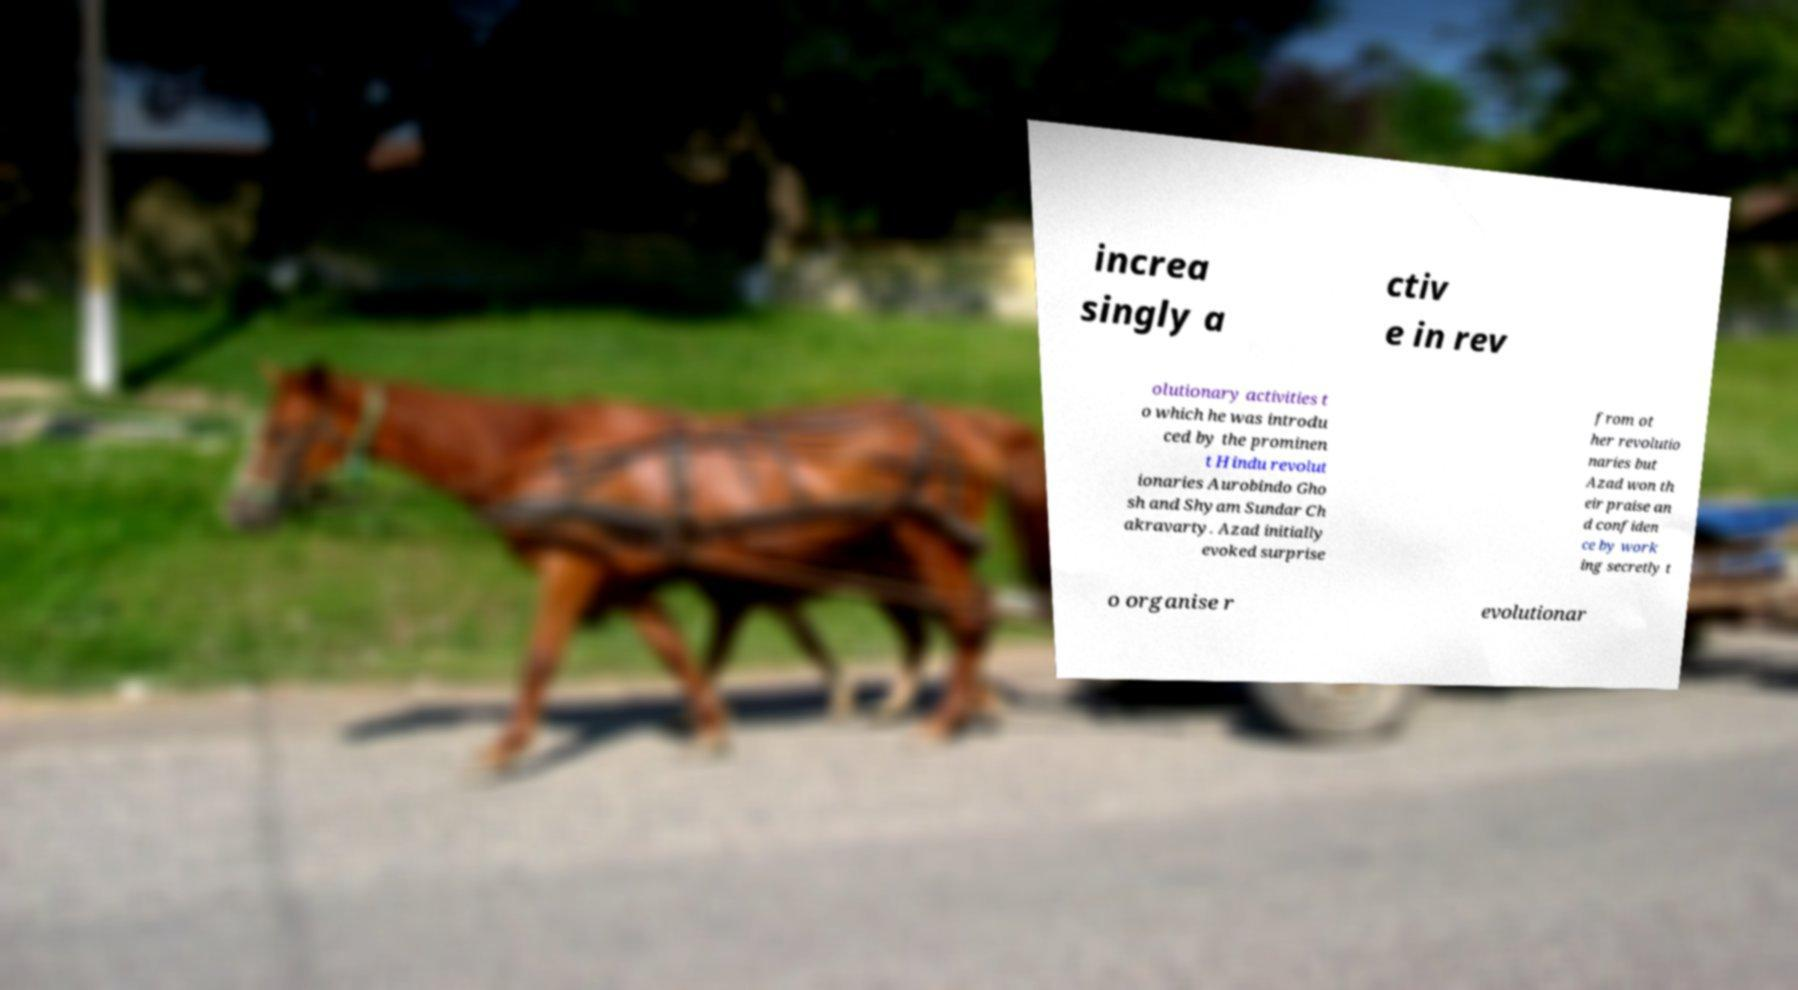Please identify and transcribe the text found in this image. increa singly a ctiv e in rev olutionary activities t o which he was introdu ced by the prominen t Hindu revolut ionaries Aurobindo Gho sh and Shyam Sundar Ch akravarty. Azad initially evoked surprise from ot her revolutio naries but Azad won th eir praise an d confiden ce by work ing secretly t o organise r evolutionar 